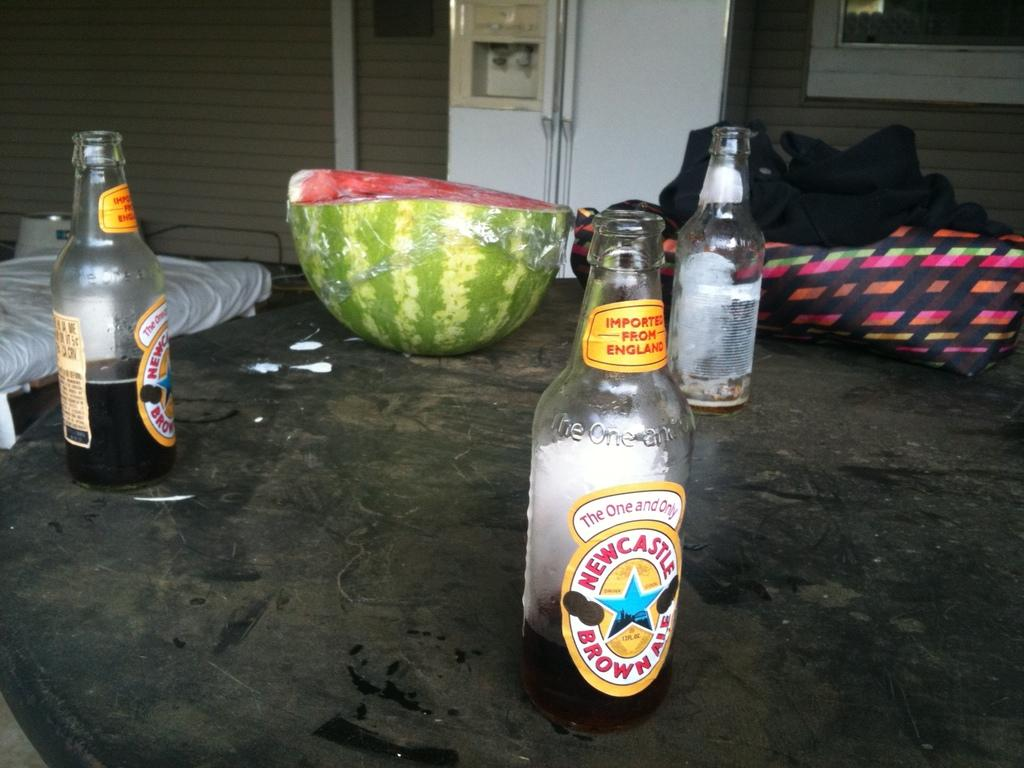How many bottles are visible in the image? There are three bottles in the image. What other fruit or vegetable can be seen in the image besides the bottles? There is a watermelon in the image. Where are the bottles and watermelon located? The objects are on a table. What type of rifle is being used to cut the watermelon in the image? There is no rifle present in the image; the watermelon is not being cut. 